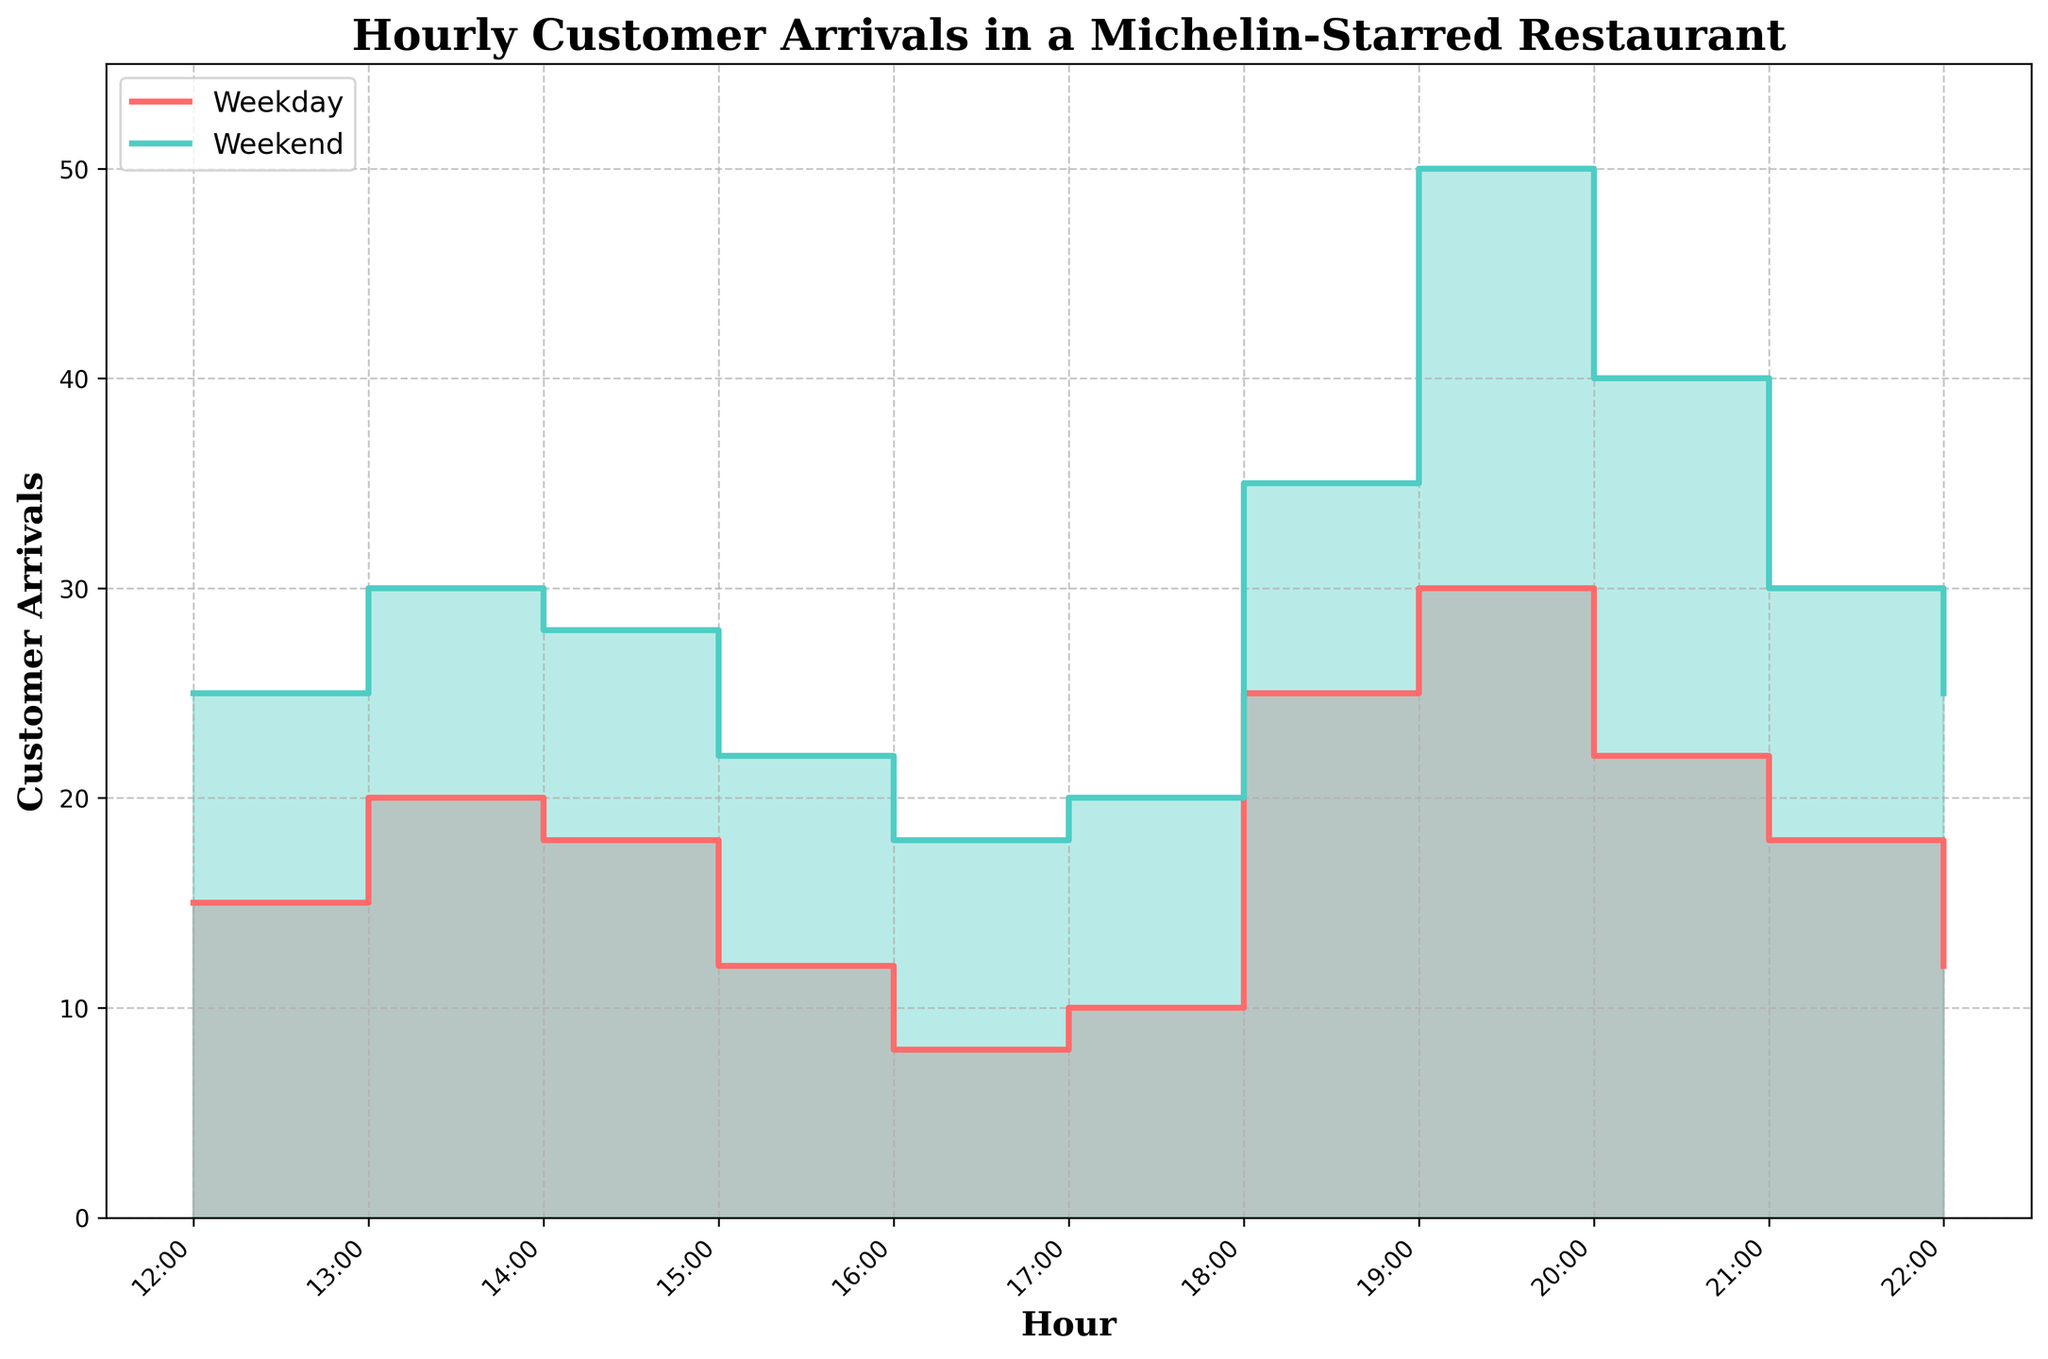What is the title of the chart? The title of the chart is displayed at the top of the figure. By reading it, we can understand the main subject of the visualization.
Answer: Hourly Customer Arrivals in a Michelin-Starred Restaurant How many data points are there for Weekday and Weekend arrivals each? By counting the number of points where the lines change direction or have data labels indicated in the step area chart, we can determine the number of data points.
Answer: 11 points each At what time do Weekend customer arrivals peak? We can find the peak time by observing the highest point on the Weekend step area chart.
Answer: 7:00 PM What is the difference in customer arrivals between Weekday and Weekend at 7:00 PM? Comparing the Weekday and Weekend values at 7:00 PM by seeing where each line is on the y-axis at this time. The Weekday value at 7:00 PM is 30 and the Weekend value is 50. Thus, the difference is 50 - 30.
Answer: 20 During which hours is the gap between weekday and weekend arrivals the smallest? By visually comparing the distances between the two lines across different hours, we can determine at which times the two values are closest. This appears to be at 4:00 PM when Weekday is 8 and Weekend is 18, but smallest at first hour 12:00 PM.
Answer: 12:00 PM What trend do customer arrivals show between 6:00 PM and 8:00 PM on both Weekdays and Weekends? Observing the step increments between 6:00 PM and 8:00 PM, we see that both lines go up, indicating an increase in customer arrivals during these hours.
Answer: Increasing What is the combined total of customer arrivals at 1:00 PM for both Weekday and Weekend? Adding the Weekday and Weekend values at 1:00 PM, which are respectively 20 and 30. The combined total is 20 + 30.
Answer: 50 Which day has higher customer arrivals at 10:00 PM, and by how much? By comparing the step heights at 10:00 PM for both lines: Weekday is 12 and Weekend is 25. The difference is 25 - 12.
Answer: Weekend by 13 How does the variability (difference between maximum and minimum values) in customer arrivals compare between Weekdays and Weekends? For Weekdays, the maximum is 30 and the minimum is 8, with a range of 30 - 8 = 22. For Weekends, the maximum is 50 and the minimum is 18, with a range of 50 - 18 = 32.
Answer: Weekends have greater variability by 10 